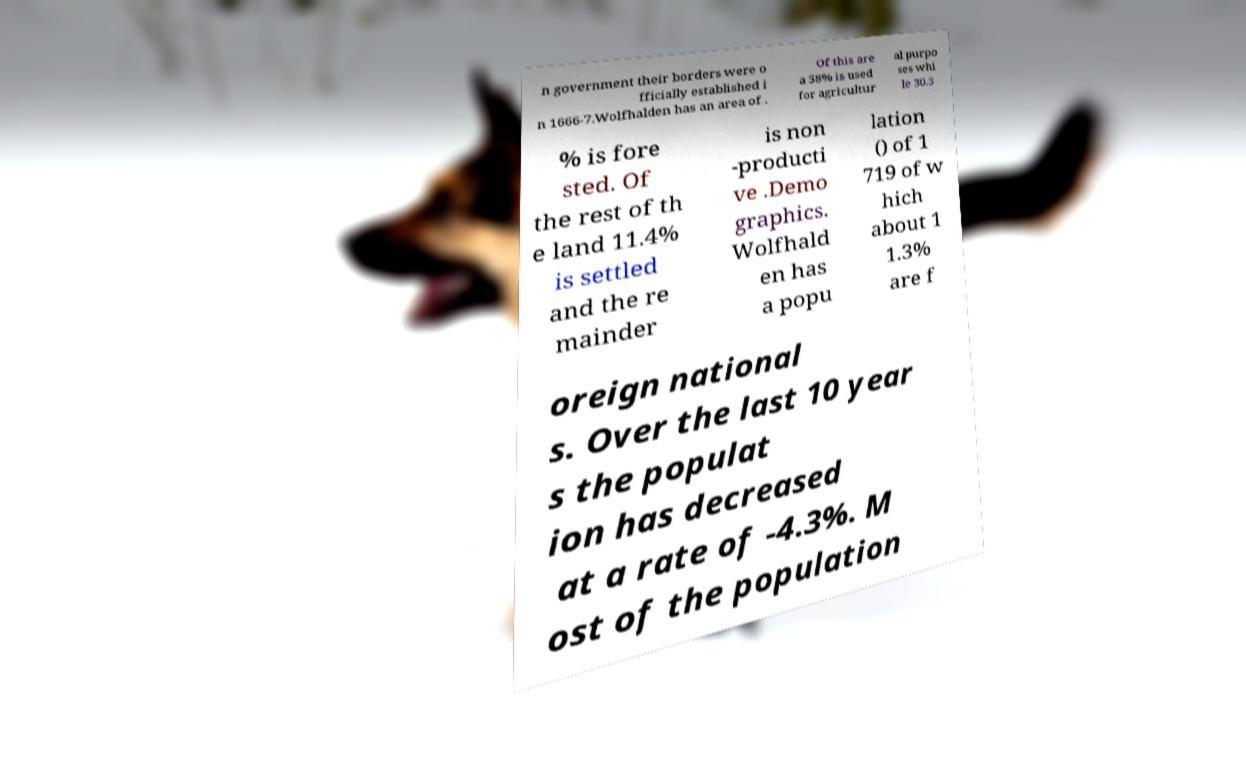There's text embedded in this image that I need extracted. Can you transcribe it verbatim? n government their borders were o fficially established i n 1666-7.Wolfhalden has an area of . Of this are a 58% is used for agricultur al purpo ses whi le 30.5 % is fore sted. Of the rest of th e land 11.4% is settled and the re mainder is non -producti ve .Demo graphics. Wolfhald en has a popu lation () of 1 719 of w hich about 1 1.3% are f oreign national s. Over the last 10 year s the populat ion has decreased at a rate of -4.3%. M ost of the population 